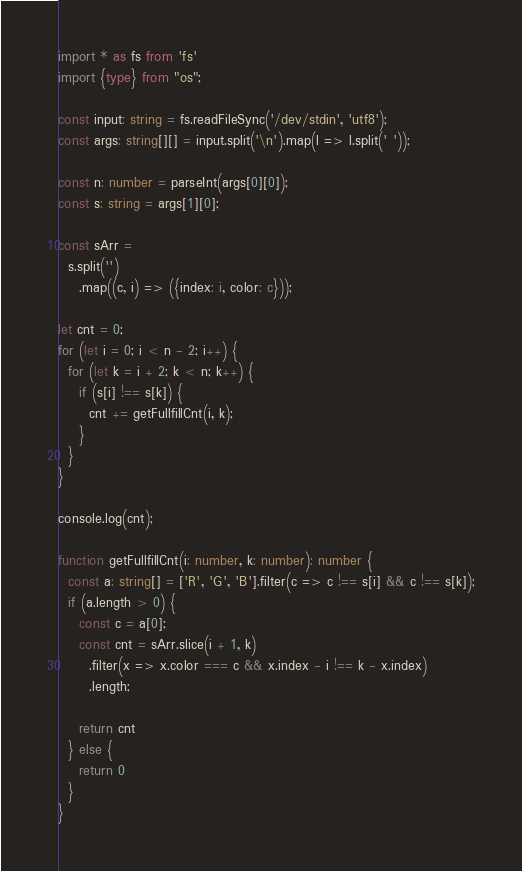Convert code to text. <code><loc_0><loc_0><loc_500><loc_500><_TypeScript_>import * as fs from 'fs'
import {type} from "os";

const input: string = fs.readFileSync('/dev/stdin', 'utf8');
const args: string[][] = input.split('\n').map(l => l.split(' '));

const n: number = parseInt(args[0][0]);
const s: string = args[1][0];

const sArr =
  s.split('')
    .map((c, i) => ({index: i, color: c}));

let cnt = 0;
for (let i = 0; i < n - 2; i++) {
  for (let k = i + 2; k < n; k++) {
    if (s[i] !== s[k]) {
      cnt += getFullfillCnt(i, k);
    }
  }
}

console.log(cnt);

function getFullfillCnt(i: number, k: number): number {
  const a: string[] = ['R', 'G', 'B'].filter(c => c !== s[i] && c !== s[k]);
  if (a.length > 0) {
    const c = a[0];
    const cnt = sArr.slice(i + 1, k)
      .filter(x => x.color === c && x.index - i !== k - x.index)
      .length;

    return cnt
  } else {
    return 0
  }
}</code> 